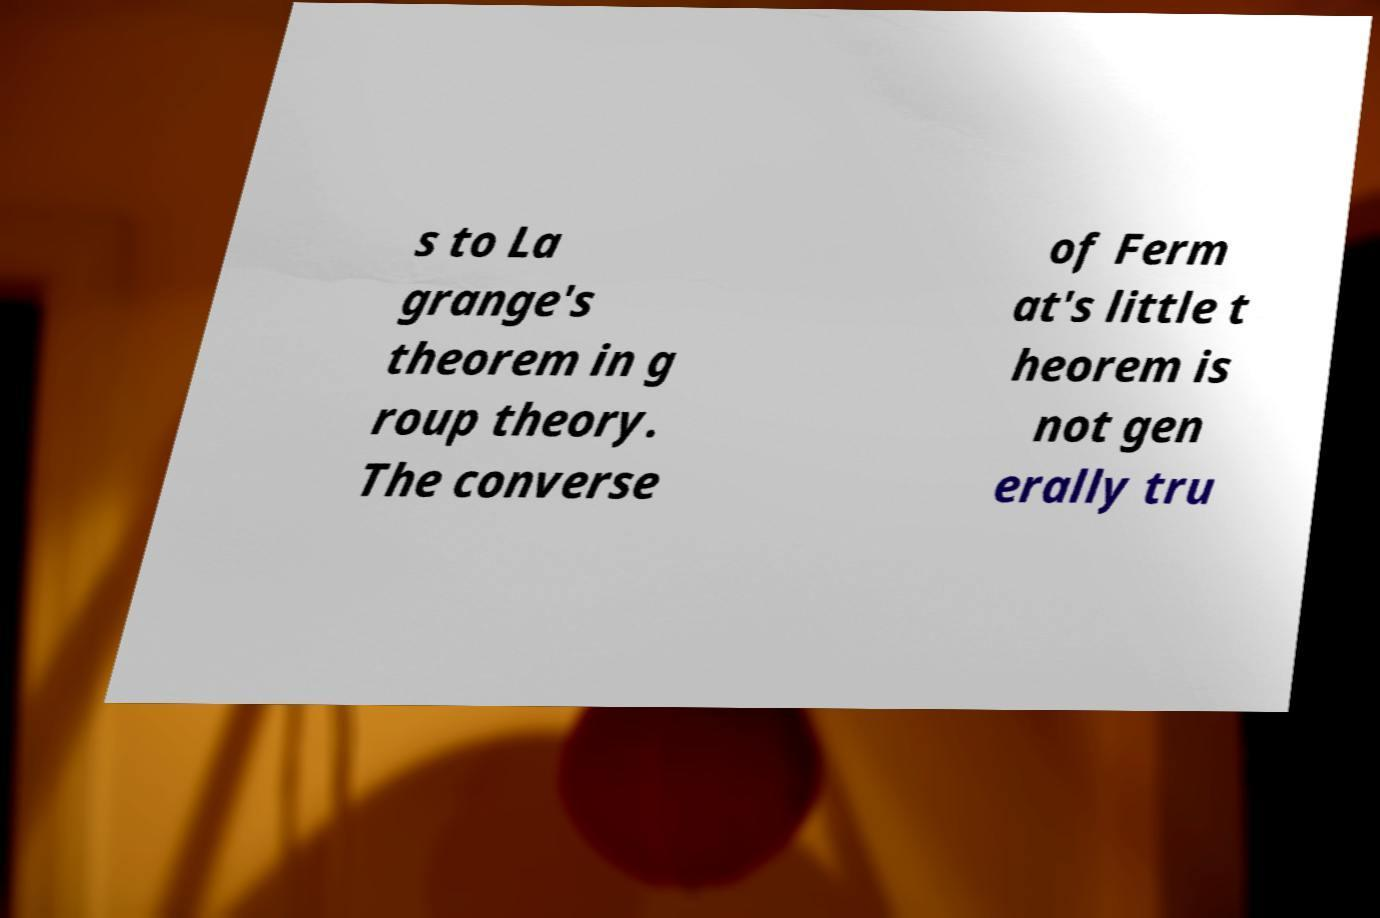I need the written content from this picture converted into text. Can you do that? s to La grange's theorem in g roup theory. The converse of Ferm at's little t heorem is not gen erally tru 